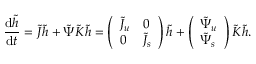<formula> <loc_0><loc_0><loc_500><loc_500>\frac { \, d \tilde { h } } { \, d t } = \tilde { J } \tilde { h } + \tilde { \Psi } \tilde { K } \tilde { h } = \left ( \begin{array} { l l } { \tilde { J } _ { u } } & { 0 } \\ { 0 } & { \tilde { J } _ { s } } \end{array} \right ) \tilde { h } + \left ( \begin{array} { l } { \tilde { \Psi } _ { u } } \\ { \tilde { \Psi } _ { s } } \end{array} \right ) \tilde { K } \tilde { h } .</formula> 